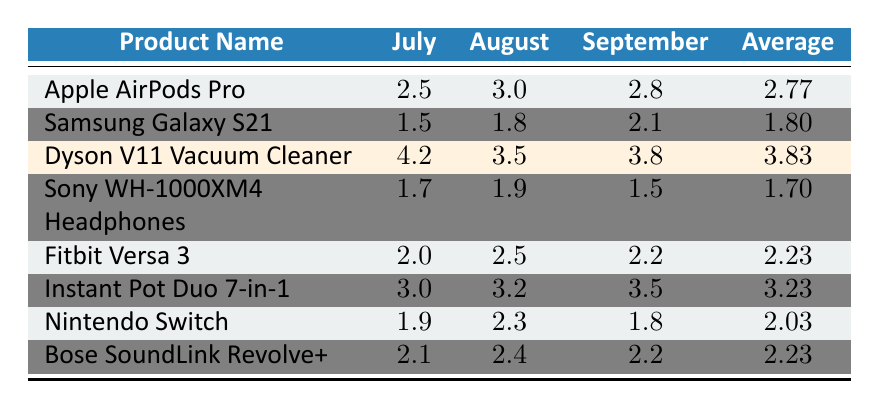What was the return rate for the Dyson V11 Vacuum Cleaner in September? According to the table, the return rate for the Dyson V11 Vacuum Cleaner in September is stated directly as 3.8.
Answer: 3.8 Which product had the highest average return rate? The products are listed with their average return rates. The Dyson V11 Vacuum Cleaner has the highest average return rate at 3.83 compared to the others.
Answer: Dyson V11 Vacuum Cleaner What is the return rate for the Samsung Galaxy S21 in August? The table lists the return rate for the Samsung Galaxy S21 in August as 1.8.
Answer: 1.8 What is the average return rate of the Apple AirPods Pro and the Instant Pot Duo 7-in-1 combined? The average return rate for the Apple AirPods Pro is 2.77 and for the Instant Pot Duo 7-in-1 is 3.23. Summing these gives 2.77 + 3.23 = 6.00. To find the average, divide by 2: 6.00 / 2 = 3.00.
Answer: 3.00 Is the average return rate for the Fitbit Versa 3 higher than that for the Sony WH-1000XM4 Headphones? The average return rate for the Fitbit Versa 3 is 2.23, while the average for the Sony WH-1000XM4 Headphones is 1.70. Since 2.23 is greater than 1.70, the statement is true.
Answer: Yes Which month had the highest overall return rate across all products? To determine this, the return rates for each month should be compared. Adding the rates for July (2.5 + 1.5 + 4.2 + 1.7 + 2.0 + 3.0 + 1.9 + 2.1 = 19.9), August (3.0 + 1.8 + 3.5 + 1.9 + 2.5 + 3.2 + 2.3 + 2.4 = 21.6), September (2.8 + 2.1 + 3.8 + 1.5 + 2.2 + 3.5 + 1.8 + 2.2 = 20.1) shows that August had the highest total at 21.6.
Answer: August What is the difference in return rates between the highest and the lowest product averages? The highest average is 3.83 for the Dyson V11 Vacuum Cleaner and the lowest is 1.70 for the Sony WH-1000XM4 Headphones. The difference is 3.83 - 1.70 = 2.13.
Answer: 2.13 Did the Nintendo Switch have a higher return rate in July than the Apple AirPods Pro? The return rate for the Nintendo Switch in July is 1.9 and for the Apple AirPods Pro is 2.5. Since 1.9 is less than 2.5, the statement is false.
Answer: No What is the return rate change for the Dyson V11 Vacuum Cleaner from July to September? The return rate for the Dyson V11 Vacuum Cleaner is 4.2 in July and 3.8 in September. The change is calculated by subtracting September from July: 4.2 - 3.8 = 0.4.
Answer: 0.4 decrease Which product returned rates averaged to be less than 2% over the last quarter? By checking the average return rates, the Samsung Galaxy S21 (1.80) and Sony WH-1000XM4 Headphones (1.70) both averaged less than 2%.
Answer: Samsung Galaxy S21 and Sony WH-1000XM4 Headphones 